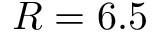Convert formula to latex. <formula><loc_0><loc_0><loc_500><loc_500>R = 6 . 5</formula> 